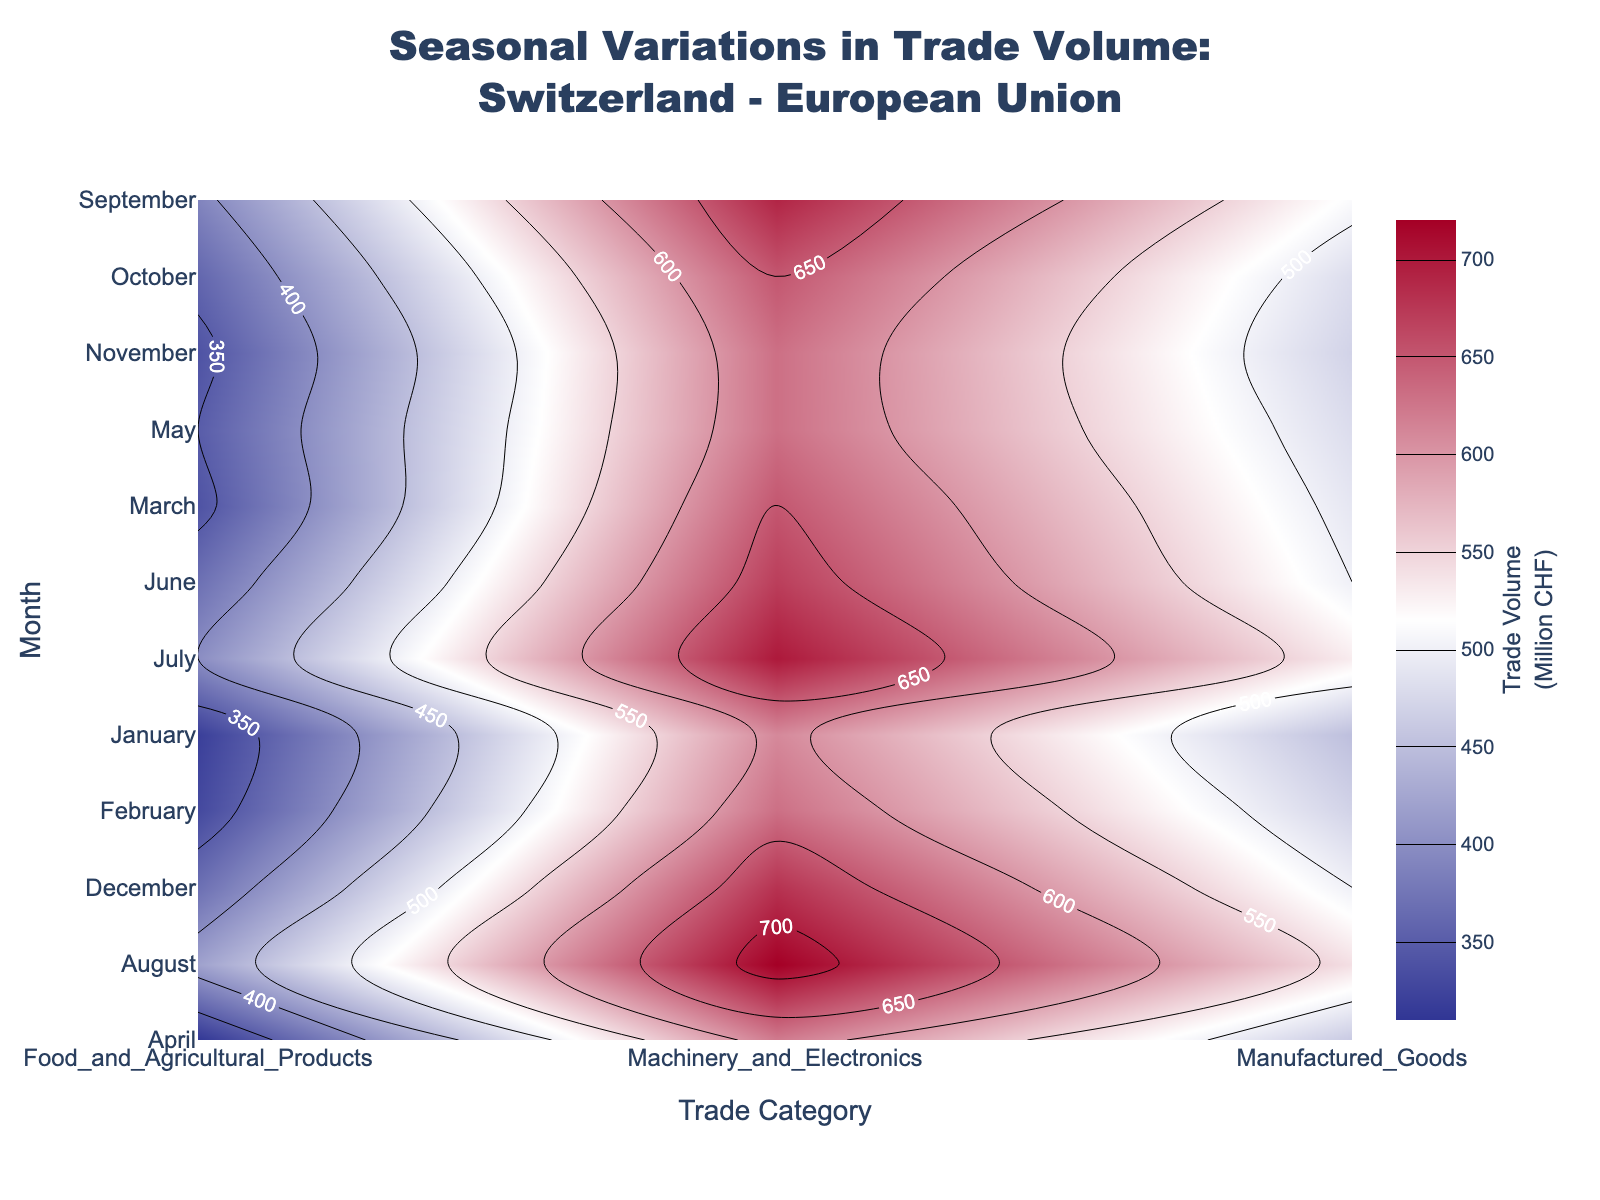What is the title of the contour plot? The title is located at the top center of the figure. It reads: "Seasonal Variations in Trade Volume: Switzerland - European Union".
Answer: Seasonal Variations in Trade Volume: Switzerland - European Union What are the labels on the x-axis and y-axis? The x-axis label reads "Trade Category" and the y-axis label reads "Month".
Answer: Trade Category, Month During which months does the Trade Volume for Manufactured Goods appear the highest? By examining the contour levels and colors along the Manufactured Goods column, the highest values are represented in the summer months, especially June, July, and August.
Answer: June, July, August What is the approximate Trade Volume for Food and Agricultural Products in January? By locating January on the y-axis and following the corresponding contour on the Food and Agricultural Products column, the approximate value shown is 320 million CHF.
Answer: 320 million CHF Which Trade Category shows the most consistent Trade Volume throughout the year? By comparing the contour patterns for each Trade Category, Machinery and Electronics appears to have the least variability, consistently indicating high trade volumes throughout the year.
Answer: Machinery and Electronics In which month does the Trade Volume for Machinery and Electronics reach its peak and what is the volume? By examining the labels and contours for Machinery and Electronics, the peak value appears in August with a trade volume of around 720 million CHF.
Answer: August, 720 million CHF Compare the Trade Volume for Food and Agricultural Products between January and July. In January, the volume is approximately 320 million CHF, and in July, it is around 400 million CHF. The volume increases by about 80 million CHF from January to July.
Answer: January: 320 million CHF, July: 400 million CHF, increase by 80 million CHF What is the average Trade Volume of Food and Agricultural Products across the first three months (January, February, March)? The volumes are 320 million CHF, 330 million CHF, and 340 million CHF. The average is calculated as (320 + 330 + 340) / 3 = 330 million CHF.
Answer: 330 million CHF Identify the Trade Category with the lowest volume in October and specify the volume. By checking the contours for October, Food and Agricultural Products show the lowest volume at approximately 360 million CHF.
Answer: Food and Agricultural Products, 360 million CHF How does the Trade Volume for Manufactured Goods change from April to June? In April, the volume is approximately 460 million CHF. By June, it increases to about 500 million CHF. The volume increases by approximately 40 million CHF from April to June.
Answer: Increase by approximately 40 million CHF 